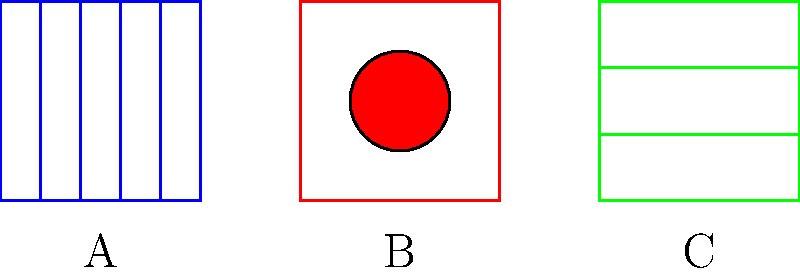Which of the above panel styles is most characteristic of Frank Miller's work in graphic novels like "Sin City"? To answer this question, let's analyze each panel style and compare them to Frank Miller's distinctive visual approach in "Sin City":

1. Panel A: This style features vertical lines dividing the panel into columns. While Miller does use panel divisions, this particular style is not his signature look.

2. Panel B: This style shows a single circular shape in the center of the panel. Miller's work, especially in "Sin City," doesn't typically focus on centered, geometric shapes.

3. Panel C: This style displays horizontal lines dividing the panel into rows. This is closest to Miller's signature style in "Sin City" for several reasons:

   a) High contrast: Miller's "Sin City" is known for its stark black and white contrast, often using strong horizontal lines to create shadows and define spaces.
   
   b) Minimalism: The simple, bold lines reflect Miller's minimalist approach in "Sin City," where he uses negative space and strong geometric shapes to create impact.
   
   c) Noir influence: The horizontal lines evoke venetian blinds or stark urban landscapes, common motifs in Miller's noir-influenced work.

Frank Miller's "Sin City" style is characterized by its use of negative space, high contrast, and bold, often horizontal lines to create a gritty, noir atmosphere. Among the given options, Panel C best represents these elements of Miller's distinctive visual style.
Answer: C 